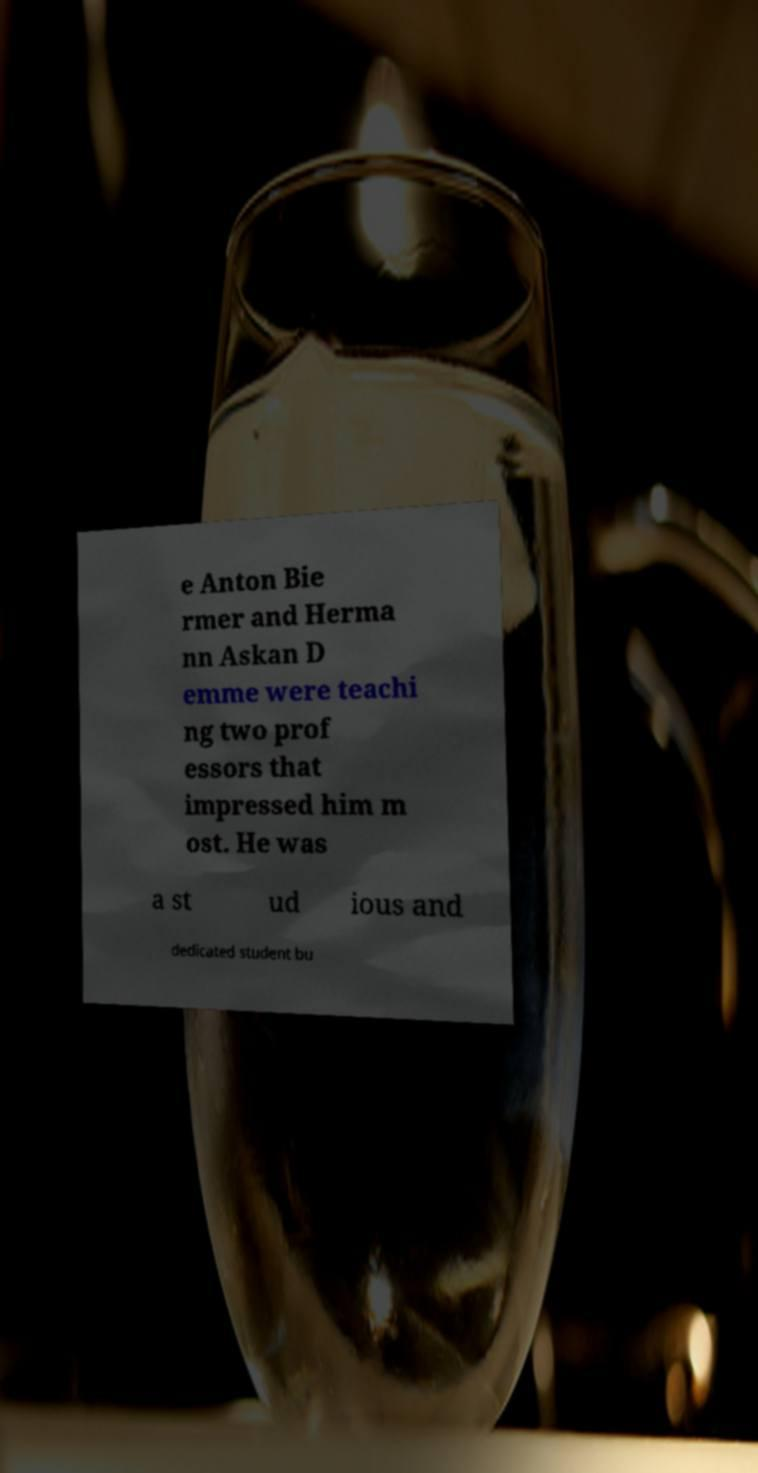Could you assist in decoding the text presented in this image and type it out clearly? e Anton Bie rmer and Herma nn Askan D emme were teachi ng two prof essors that impressed him m ost. He was a st ud ious and dedicated student bu 